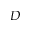Convert formula to latex. <formula><loc_0><loc_0><loc_500><loc_500>D</formula> 